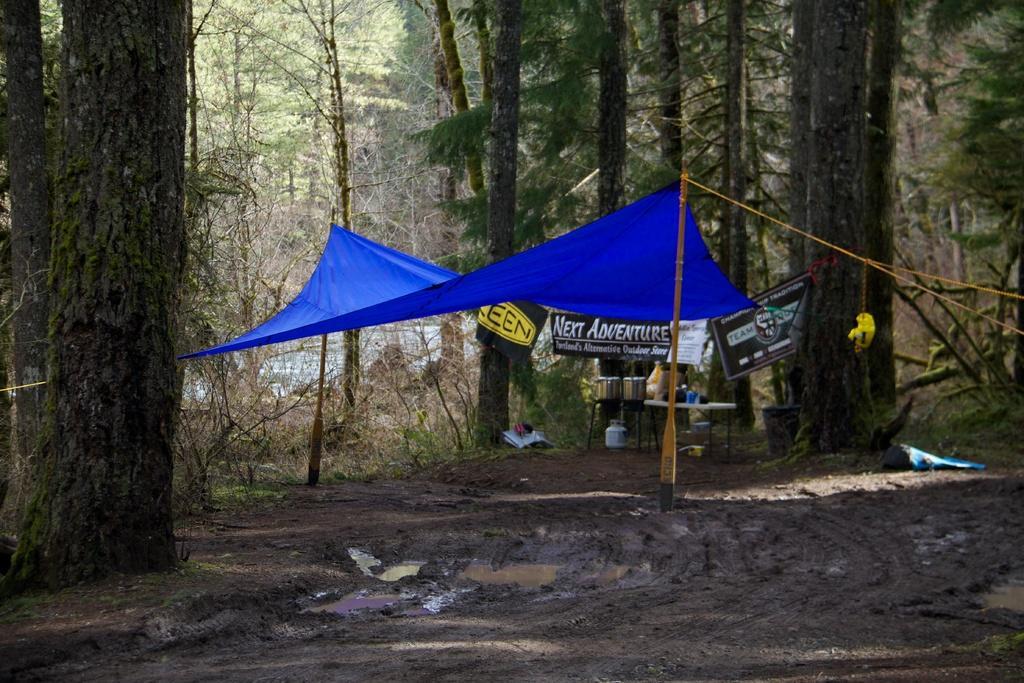How would you summarize this image in a sentence or two? In this image in the center there is one cloth and some boards, pole, rope. At the bottom there is mud, and in the background there are some trees and a pond. 